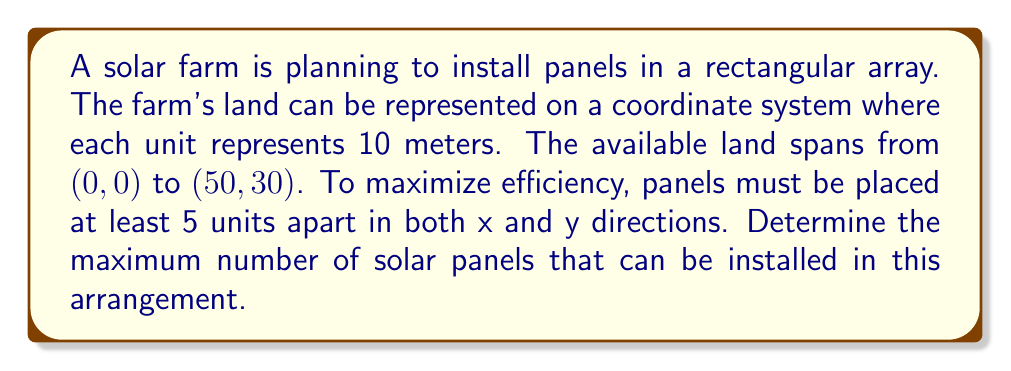Solve this math problem. To solve this problem, we'll follow these steps:

1. Determine the number of rows and columns of panels:
   - X-axis: The land spans from 0 to 50 units
   - Y-axis: The land spans from 0 to 30 units
   - Panels must be 5 units apart in both directions

   For the X-axis:
   $$ \text{Number of columns} = \left\lfloor\frac{50}{5}\right\rfloor + 1 = 11 $$

   For the Y-axis:
   $$ \text{Number of rows} = \left\lfloor\frac{30}{5}\right\rfloor + 1 = 7 $$

   Where $\lfloor \cdot \rfloor$ represents the floor function.

2. Calculate the total number of panels:
   $$ \text{Total panels} = \text{Number of columns} \times \text{Number of rows} $$
   $$ \text{Total panels} = 11 \times 7 = 77 $$

3. Verify the arrangement:
   The panels will be placed at coordinates $(5i, 5j)$ where $i = 0, 1, 2, ..., 10$ and $j = 0, 1, 2, ..., 6$.

[asy]
unitsize(4mm);
for(int i = 0; i <= 10; ++i) {
  for(int j = 0; j <= 6; ++j) {
    dot((5i, 5j));
  }
}
draw((0,0)--(50,0)--(50,30)--(0,30)--cycle);
label("(0,0)", (0,0), SW);
label("(50,30)", (50,30), NE);
[/asy]

This arrangement ensures that all panels are within the specified land area and maintain the required 5-unit spacing.
Answer: 77 solar panels 